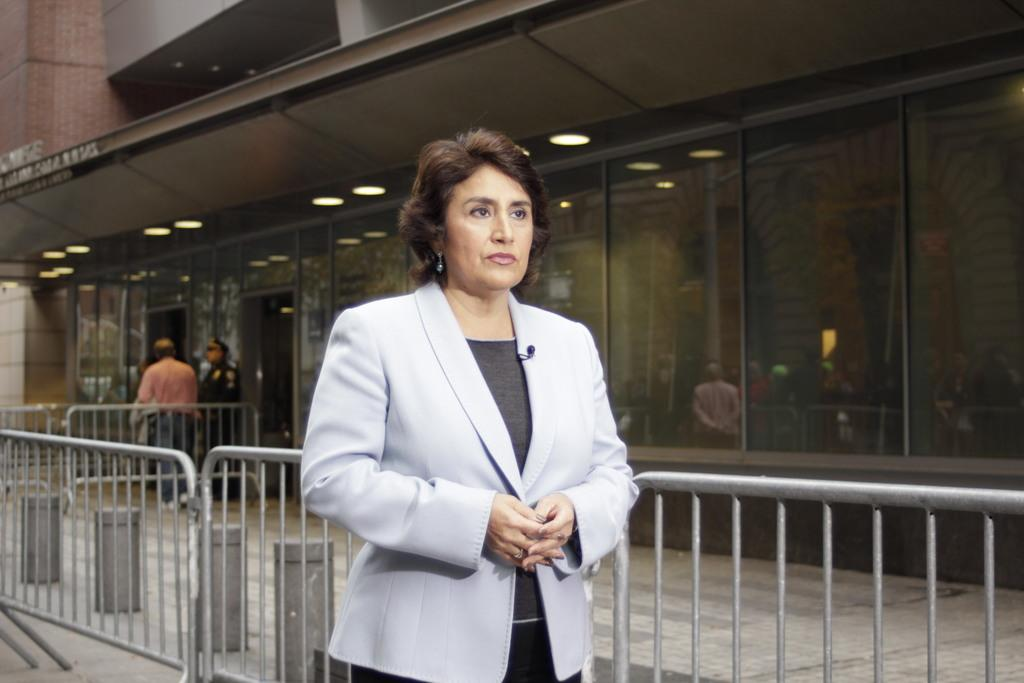Who is the main subject in the image? There is a woman in the image. What is the woman wearing? The woman is wearing a gray suit. What is the woman doing in the image? The woman is standing. What can be seen behind the woman? There is a fencing behind the woman. What is visible in the background of the image? There is a building in the background of the image. What type of music can be heard playing in the background of the image? There is no music present in the image, as it is a still photograph. 